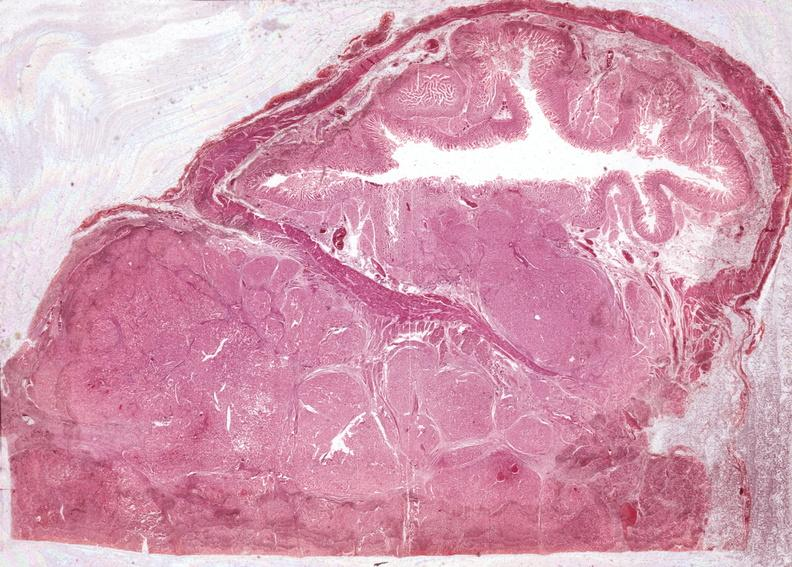what is present?
Answer the question using a single word or phrase. Pancreas 